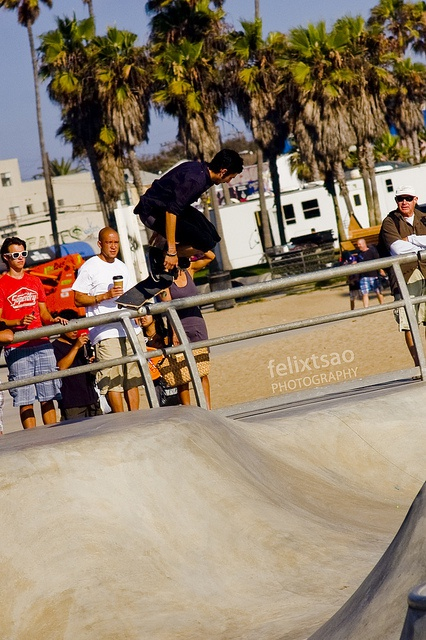Describe the objects in this image and their specific colors. I can see people in olive, black, maroon, red, and gray tones, people in olive, black, red, darkgray, and gray tones, people in olive, white, maroon, red, and black tones, people in olive, black, lightgray, and maroon tones, and people in olive, black, maroon, red, and darkgray tones in this image. 